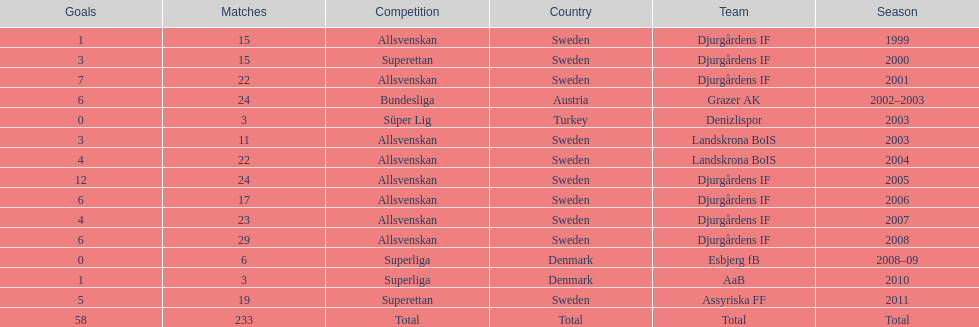How many teams had above 20 matches in the season? 6. 